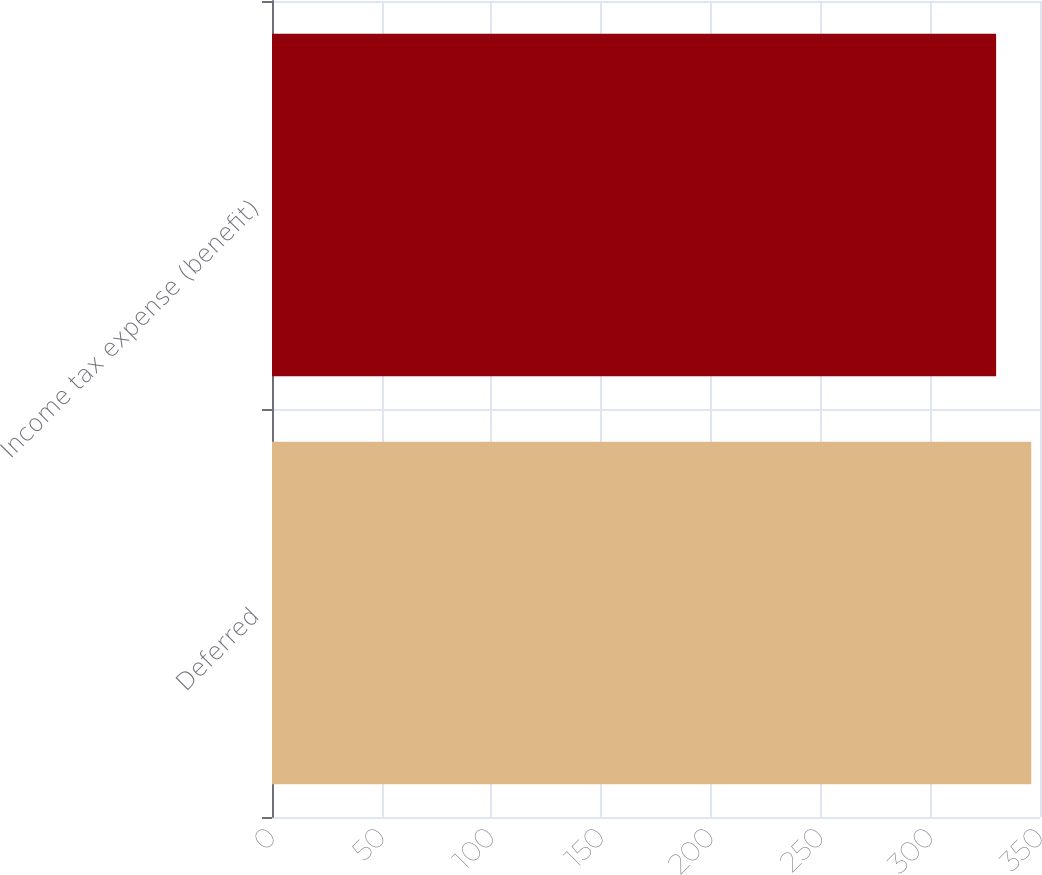Convert chart to OTSL. <chart><loc_0><loc_0><loc_500><loc_500><bar_chart><fcel>Deferred<fcel>Income tax expense (benefit)<nl><fcel>346<fcel>330<nl></chart> 